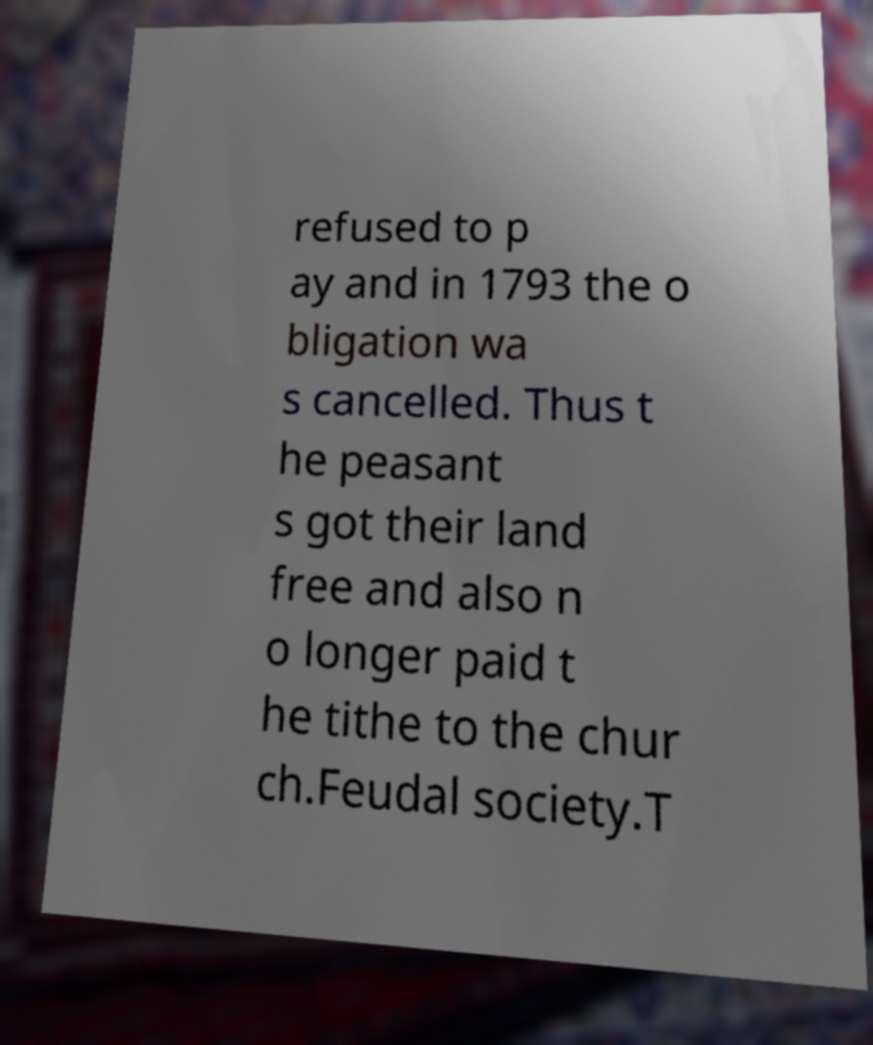Could you extract and type out the text from this image? refused to p ay and in 1793 the o bligation wa s cancelled. Thus t he peasant s got their land free and also n o longer paid t he tithe to the chur ch.Feudal society.T 